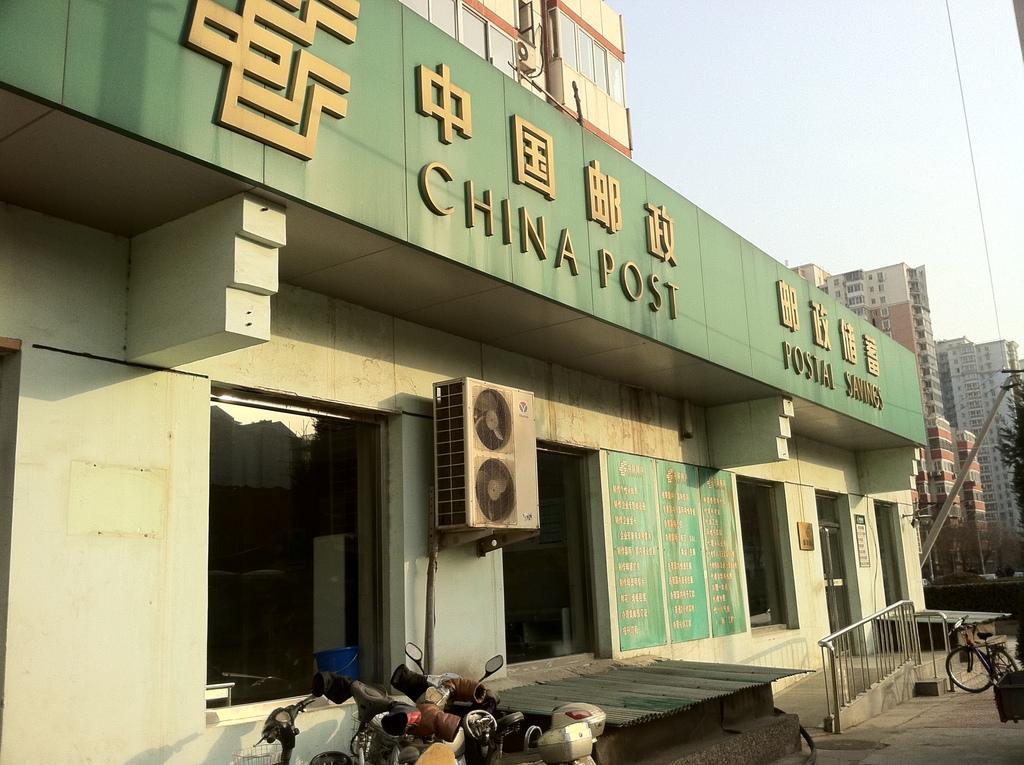How would you summarize this image in a sentence or two? In this image we can see vehicles parked here, air conditioner fans, name board to the house, glass windows, steel railing, buildings current pole, wires, trees and sky in the background. 